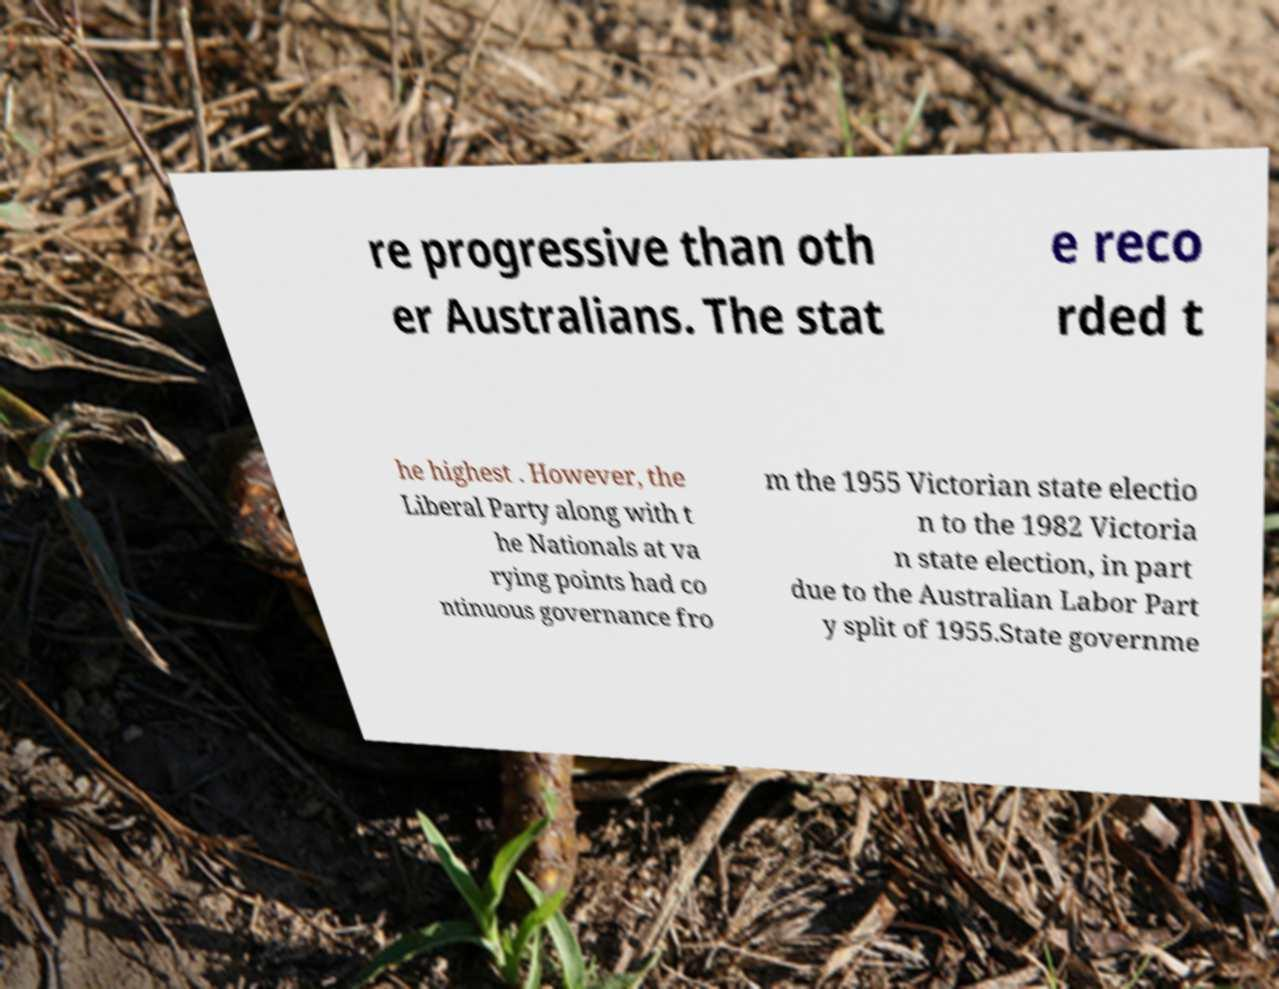Could you extract and type out the text from this image? re progressive than oth er Australians. The stat e reco rded t he highest . However, the Liberal Party along with t he Nationals at va rying points had co ntinuous governance fro m the 1955 Victorian state electio n to the 1982 Victoria n state election, in part due to the Australian Labor Part y split of 1955.State governme 